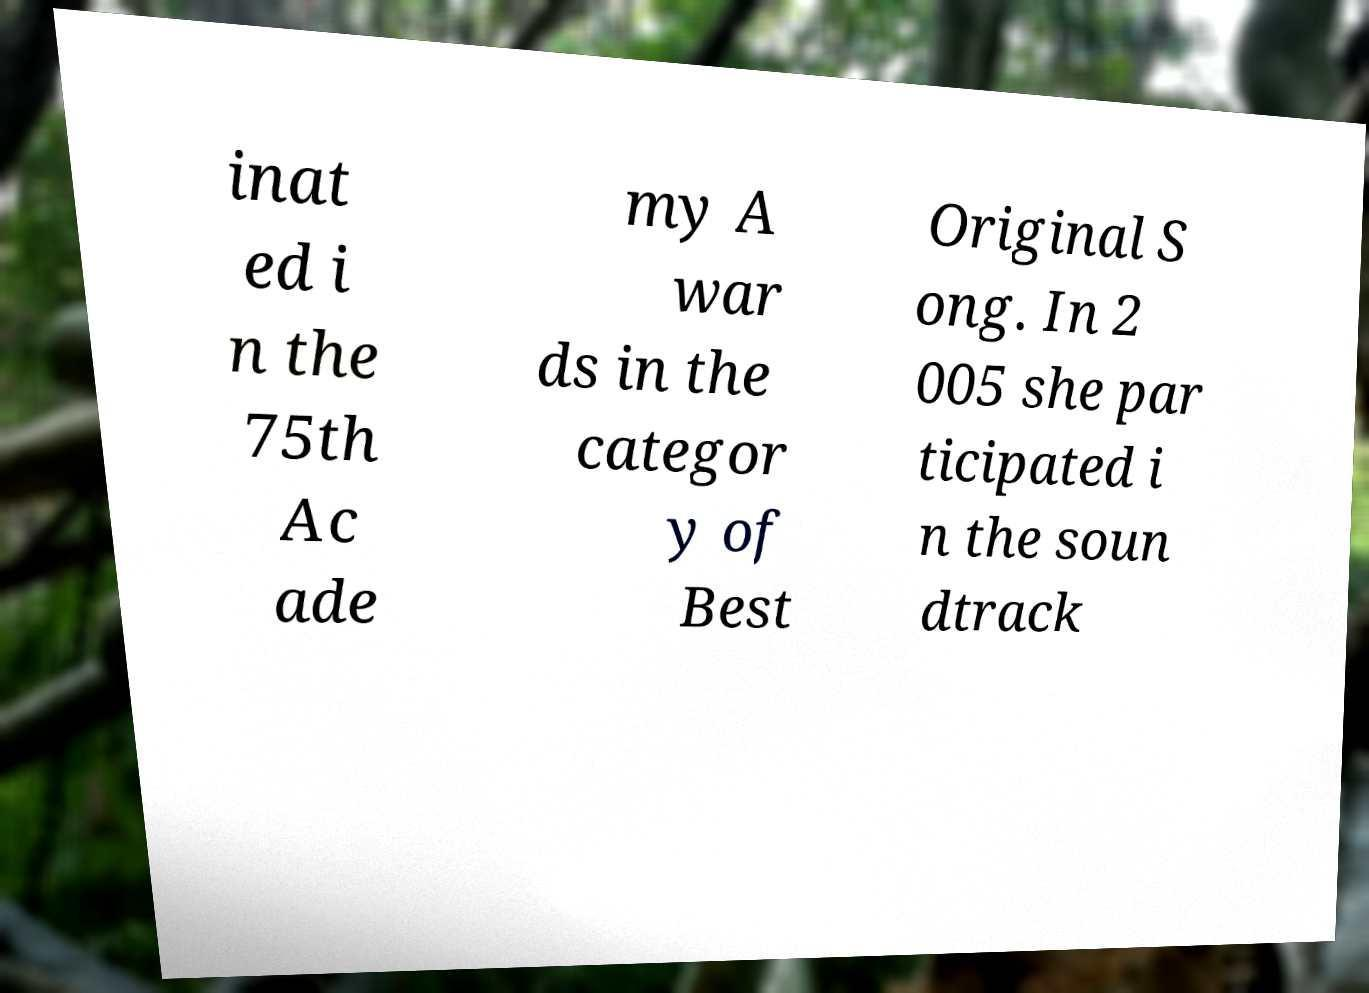Can you accurately transcribe the text from the provided image for me? inat ed i n the 75th Ac ade my A war ds in the categor y of Best Original S ong. In 2 005 she par ticipated i n the soun dtrack 